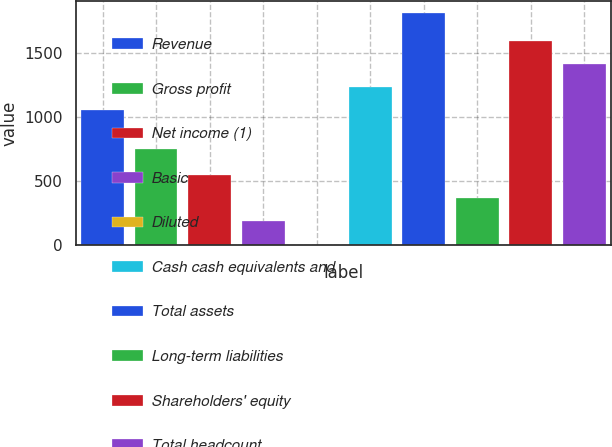Convert chart to OTSL. <chart><loc_0><loc_0><loc_500><loc_500><bar_chart><fcel>Revenue<fcel>Gross profit<fcel>Net income (1)<fcel>Basic<fcel>Diluted<fcel>Cash cash equivalents and<fcel>Total assets<fcel>Long-term liabilities<fcel>Shareholders' equity<fcel>Total headcount<nl><fcel>1052.2<fcel>751.1<fcel>547.07<fcel>186.31<fcel>5.93<fcel>1232.58<fcel>1809.7<fcel>366.69<fcel>1593.34<fcel>1412.96<nl></chart> 